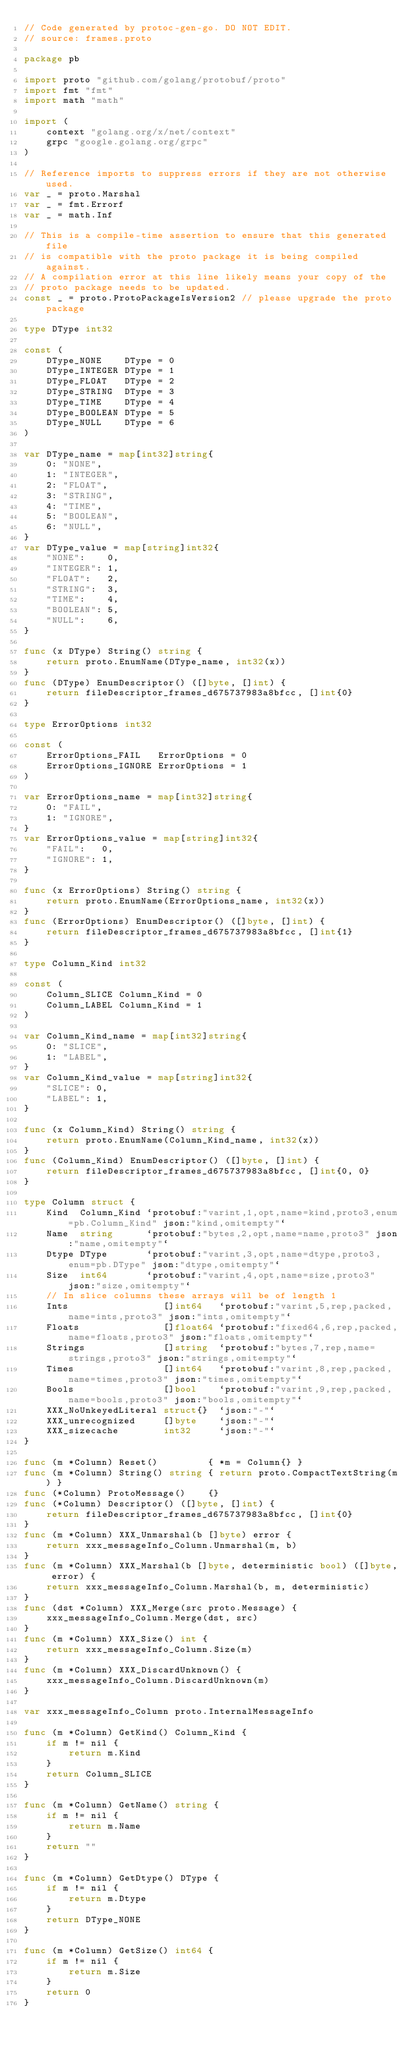<code> <loc_0><loc_0><loc_500><loc_500><_Go_>// Code generated by protoc-gen-go. DO NOT EDIT.
// source: frames.proto

package pb

import proto "github.com/golang/protobuf/proto"
import fmt "fmt"
import math "math"

import (
	context "golang.org/x/net/context"
	grpc "google.golang.org/grpc"
)

// Reference imports to suppress errors if they are not otherwise used.
var _ = proto.Marshal
var _ = fmt.Errorf
var _ = math.Inf

// This is a compile-time assertion to ensure that this generated file
// is compatible with the proto package it is being compiled against.
// A compilation error at this line likely means your copy of the
// proto package needs to be updated.
const _ = proto.ProtoPackageIsVersion2 // please upgrade the proto package

type DType int32

const (
	DType_NONE    DType = 0
	DType_INTEGER DType = 1
	DType_FLOAT   DType = 2
	DType_STRING  DType = 3
	DType_TIME    DType = 4
	DType_BOOLEAN DType = 5
	DType_NULL    DType = 6
)

var DType_name = map[int32]string{
	0: "NONE",
	1: "INTEGER",
	2: "FLOAT",
	3: "STRING",
	4: "TIME",
	5: "BOOLEAN",
	6: "NULL",
}
var DType_value = map[string]int32{
	"NONE":    0,
	"INTEGER": 1,
	"FLOAT":   2,
	"STRING":  3,
	"TIME":    4,
	"BOOLEAN": 5,
	"NULL":    6,
}

func (x DType) String() string {
	return proto.EnumName(DType_name, int32(x))
}
func (DType) EnumDescriptor() ([]byte, []int) {
	return fileDescriptor_frames_d675737983a8bfcc, []int{0}
}

type ErrorOptions int32

const (
	ErrorOptions_FAIL   ErrorOptions = 0
	ErrorOptions_IGNORE ErrorOptions = 1
)

var ErrorOptions_name = map[int32]string{
	0: "FAIL",
	1: "IGNORE",
}
var ErrorOptions_value = map[string]int32{
	"FAIL":   0,
	"IGNORE": 1,
}

func (x ErrorOptions) String() string {
	return proto.EnumName(ErrorOptions_name, int32(x))
}
func (ErrorOptions) EnumDescriptor() ([]byte, []int) {
	return fileDescriptor_frames_d675737983a8bfcc, []int{1}
}

type Column_Kind int32

const (
	Column_SLICE Column_Kind = 0
	Column_LABEL Column_Kind = 1
)

var Column_Kind_name = map[int32]string{
	0: "SLICE",
	1: "LABEL",
}
var Column_Kind_value = map[string]int32{
	"SLICE": 0,
	"LABEL": 1,
}

func (x Column_Kind) String() string {
	return proto.EnumName(Column_Kind_name, int32(x))
}
func (Column_Kind) EnumDescriptor() ([]byte, []int) {
	return fileDescriptor_frames_d675737983a8bfcc, []int{0, 0}
}

type Column struct {
	Kind  Column_Kind `protobuf:"varint,1,opt,name=kind,proto3,enum=pb.Column_Kind" json:"kind,omitempty"`
	Name  string      `protobuf:"bytes,2,opt,name=name,proto3" json:"name,omitempty"`
	Dtype DType       `protobuf:"varint,3,opt,name=dtype,proto3,enum=pb.DType" json:"dtype,omitempty"`
	Size  int64       `protobuf:"varint,4,opt,name=size,proto3" json:"size,omitempty"`
	// In slice columns these arrays will be of length 1
	Ints                 []int64   `protobuf:"varint,5,rep,packed,name=ints,proto3" json:"ints,omitempty"`
	Floats               []float64 `protobuf:"fixed64,6,rep,packed,name=floats,proto3" json:"floats,omitempty"`
	Strings              []string  `protobuf:"bytes,7,rep,name=strings,proto3" json:"strings,omitempty"`
	Times                []int64   `protobuf:"varint,8,rep,packed,name=times,proto3" json:"times,omitempty"`
	Bools                []bool    `protobuf:"varint,9,rep,packed,name=bools,proto3" json:"bools,omitempty"`
	XXX_NoUnkeyedLiteral struct{}  `json:"-"`
	XXX_unrecognized     []byte    `json:"-"`
	XXX_sizecache        int32     `json:"-"`
}

func (m *Column) Reset()         { *m = Column{} }
func (m *Column) String() string { return proto.CompactTextString(m) }
func (*Column) ProtoMessage()    {}
func (*Column) Descriptor() ([]byte, []int) {
	return fileDescriptor_frames_d675737983a8bfcc, []int{0}
}
func (m *Column) XXX_Unmarshal(b []byte) error {
	return xxx_messageInfo_Column.Unmarshal(m, b)
}
func (m *Column) XXX_Marshal(b []byte, deterministic bool) ([]byte, error) {
	return xxx_messageInfo_Column.Marshal(b, m, deterministic)
}
func (dst *Column) XXX_Merge(src proto.Message) {
	xxx_messageInfo_Column.Merge(dst, src)
}
func (m *Column) XXX_Size() int {
	return xxx_messageInfo_Column.Size(m)
}
func (m *Column) XXX_DiscardUnknown() {
	xxx_messageInfo_Column.DiscardUnknown(m)
}

var xxx_messageInfo_Column proto.InternalMessageInfo

func (m *Column) GetKind() Column_Kind {
	if m != nil {
		return m.Kind
	}
	return Column_SLICE
}

func (m *Column) GetName() string {
	if m != nil {
		return m.Name
	}
	return ""
}

func (m *Column) GetDtype() DType {
	if m != nil {
		return m.Dtype
	}
	return DType_NONE
}

func (m *Column) GetSize() int64 {
	if m != nil {
		return m.Size
	}
	return 0
}
</code> 